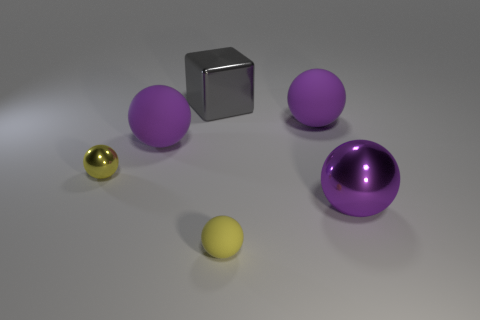What number of purple spheres are behind the tiny yellow metallic thing and right of the small rubber object? There is one purple sphere situated behind the tiny yellow metallic sphere and to the right of the small grey rubber cube. 